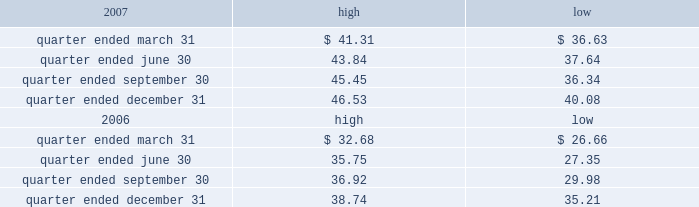Part ii item 5 .
Market for registrant 2019s common equity , related stockholder matters and issuer purchases of equity securities the table presents reported quarterly high and low per share sale prices of our class a common stock on the new york stock exchange ( 201cnyse 201d ) for the years 2007 and 2006. .
On february 29 , 2008 , the closing price of our class a common stock was $ 38.44 per share as reported on the nyse .
As of february 29 , 2008 , we had 395748826 outstanding shares of class a common stock and 528 registered holders .
Dividends we have never paid a dividend on any class of our common stock .
We anticipate that we may retain future earnings , if any , to fund the development and growth of our business .
The indentures governing our 7.50% ( 7.50 % ) senior notes due 2012 ( 201c7.50% ( 201c7.50 % ) notes 201d ) and our 7.125% ( 7.125 % ) senior notes due 2012 ( 201c7.125% ( 201c7.125 % ) notes 201d ) may prohibit us from paying dividends to our stockholders unless we satisfy certain financial covenants .
The loan agreement for our revolving credit facility and the indentures governing the terms of our 7.50% ( 7.50 % ) notes and 7.125% ( 7.125 % ) notes contain covenants that restrict our ability to pay dividends unless certain financial covenants are satisfied .
In addition , while spectrasite and its subsidiaries are classified as unrestricted subsidiaries under the indentures for our 7.50% ( 7.50 % ) notes and 7.125% ( 7.125 % ) notes , certain of spectrasite 2019s subsidiaries are subject to restrictions on the amount of cash that they can distribute to us under the loan agreement related to our securitization .
For more information about the restrictions under the loan agreement for the revolving credit facility , our notes indentures and the loan agreement related to the securitization , see item 7 of this annual report under the caption 201cmanagement 2019s discussion and analysis of financial condition and results of operations 2014liquidity and capital resources 2014factors affecting sources of liquidity 201d and note 3 to our consolidated financial statements included in this annual report. .
What is the growth rate in the price of shares from the highest value during the quarter ended december 31 , 2007 and the closing price on february 29 , 2008? 
Computations: ((38.44 - 46.53) / 46.53)
Answer: -0.17387. 